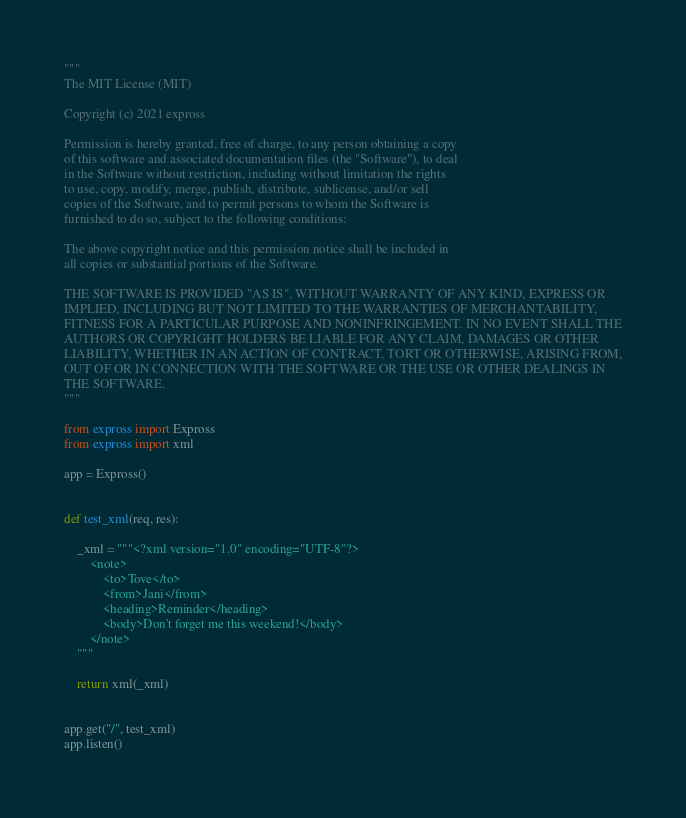<code> <loc_0><loc_0><loc_500><loc_500><_Python_>"""
The MIT License (MIT)

Copyright (c) 2021 expross

Permission is hereby granted, free of charge, to any person obtaining a copy
of this software and associated documentation files (the "Software"), to deal
in the Software without restriction, including without limitation the rights
to use, copy, modify, merge, publish, distribute, sublicense, and/or sell
copies of the Software, and to permit persons to whom the Software is
furnished to do so, subject to the following conditions:

The above copyright notice and this permission notice shall be included in
all copies or substantial portions of the Software.

THE SOFTWARE IS PROVIDED "AS IS", WITHOUT WARRANTY OF ANY KIND, EXPRESS OR
IMPLIED, INCLUDING BUT NOT LIMITED TO THE WARRANTIES OF MERCHANTABILITY,
FITNESS FOR A PARTICULAR PURPOSE AND NONINFRINGEMENT. IN NO EVENT SHALL THE
AUTHORS OR COPYRIGHT HOLDERS BE LIABLE FOR ANY CLAIM, DAMAGES OR OTHER
LIABILITY, WHETHER IN AN ACTION OF CONTRACT, TORT OR OTHERWISE, ARISING FROM,
OUT OF OR IN CONNECTION WITH THE SOFTWARE OR THE USE OR OTHER DEALINGS IN
THE SOFTWARE.
"""

from expross import Expross
from expross import xml

app = Expross()


def test_xml(req, res):

    _xml = """<?xml version="1.0" encoding="UTF-8"?>
        <note>
            <to>Tove</to>
            <from>Jani</from>
            <heading>Reminder</heading>
            <body>Don't forget me this weekend!</body>
        </note>
    """

    return xml(_xml)


app.get("/", test_xml)
app.listen()
</code> 